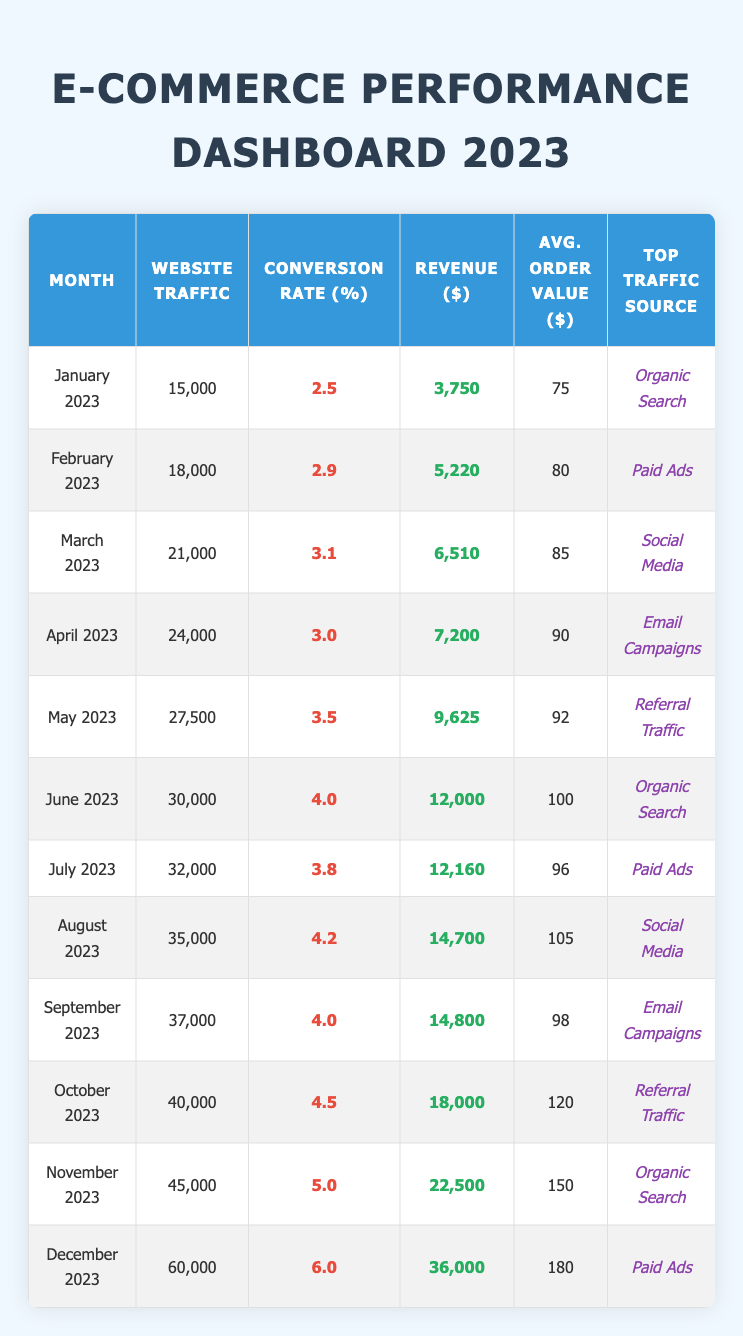What's the highest website traffic recorded in 2023? The highest website traffic is in December 2023, where it reached 60,000.
Answer: 60,000 What was the conversion rate for April 2023? For April 2023, the conversion rate was 3.0%.
Answer: 3.0% Which month had the lowest customer acquisition cost? The month with the lowest customer acquisition cost was April 2023 at $15.
Answer: April 2023 What's the average conversion rate across all months in 2023? The average conversion rate is calculated by summing all individual conversion rates (2.5 + 2.9 + 3.1 + 3.0 + 3.5 + 4.0 + 3.8 + 4.2 + 4.0 + 4.5 + 5.0 + 6.0 =  47.5) and dividing by the number of months (12). Thus, 47.5 / 12 = about 3.96%.
Answer: 3.96% Did the website traffic increase every month in 2023? Yes, the data shows that website traffic increased every month from January to December 2023.
Answer: Yes What was the difference in revenue between November and January 2023? Revenue in November 2023 was $22,500 and in January 2023 was $3,750. The difference is $22,500 - $3,750 = $18,750.
Answer: $18,750 What was the average order value in the month with the highest conversion rate? In December 2023, the highest conversion rate was 6.0%, and the average order value was $180.
Answer: $180 Which traffic source was the most common in the last quarter of 2023? The last quarter includes October, November, and December, where the top traffic sources were Referral Traffic, Organic Search, and Paid Ads respectively. Hence, there wasn't a single most common source; each month had a different top source.
Answer: None What is the median website traffic for the year? To find the median, we list the website traffic values in order: 15,000, 18,000, 21,000, 24,000, 27,500, 30,000, 32,000, 35,000, 37,000, 40,000, 45,000, 60,000. There are 12 values, so the median is the average of the 6th and 7th values: (30,000 + 32,000) / 2 = 31,000.
Answer: 31,000 In which month did the average order value surpass $100? The average order value surpassed $100 in August 2023 when it reached $105.
Answer: August 2023 What was the total revenue generated in the first half of the year (January to June)? The total revenue for the first half (3,750 + 5,220 + 6,510 + 7,200 + 9,625 + 12,000 = 44,305) was $44,305.
Answer: $44,305 